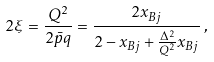<formula> <loc_0><loc_0><loc_500><loc_500>2 \xi = \frac { Q ^ { 2 } } { 2 { \bar { p } } q } = \frac { 2 x _ { B j } } { 2 - x _ { B j } + \frac { \Delta ^ { 2 } } { Q ^ { 2 } } x _ { B j } } \, ,</formula> 